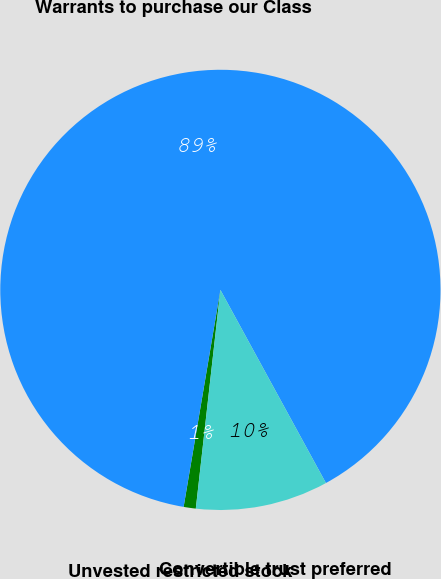Convert chart. <chart><loc_0><loc_0><loc_500><loc_500><pie_chart><fcel>Unvested restricted stock<fcel>Warrants to purchase our Class<fcel>Convertible trust preferred<nl><fcel>0.89%<fcel>89.37%<fcel>9.74%<nl></chart> 